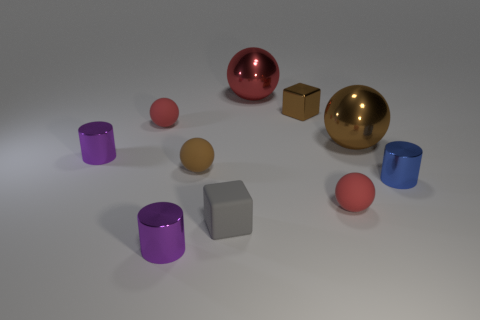What material is the blue thing that is the same size as the gray rubber object?
Make the answer very short. Metal. Is there a red metallic cylinder of the same size as the blue object?
Make the answer very short. No. Does the cylinder behind the blue metallic thing have the same color as the big shiny sphere that is to the left of the large brown sphere?
Provide a succinct answer. No. How many metal objects are purple cylinders or red objects?
Ensure brevity in your answer.  3. There is a small red sphere that is to the right of the purple cylinder in front of the blue object; how many brown metallic things are left of it?
Your answer should be very brief. 1. The brown block that is the same material as the small blue thing is what size?
Your answer should be compact. Small. How many small things are the same color as the small metallic cube?
Give a very brief answer. 1. Does the purple shiny cylinder that is behind the matte block have the same size as the brown matte object?
Make the answer very short. Yes. What is the color of the metallic cylinder that is both behind the tiny rubber cube and on the left side of the large red shiny sphere?
Offer a terse response. Purple. What number of things are tiny gray rubber things or metal things left of the gray matte thing?
Your answer should be very brief. 3. 